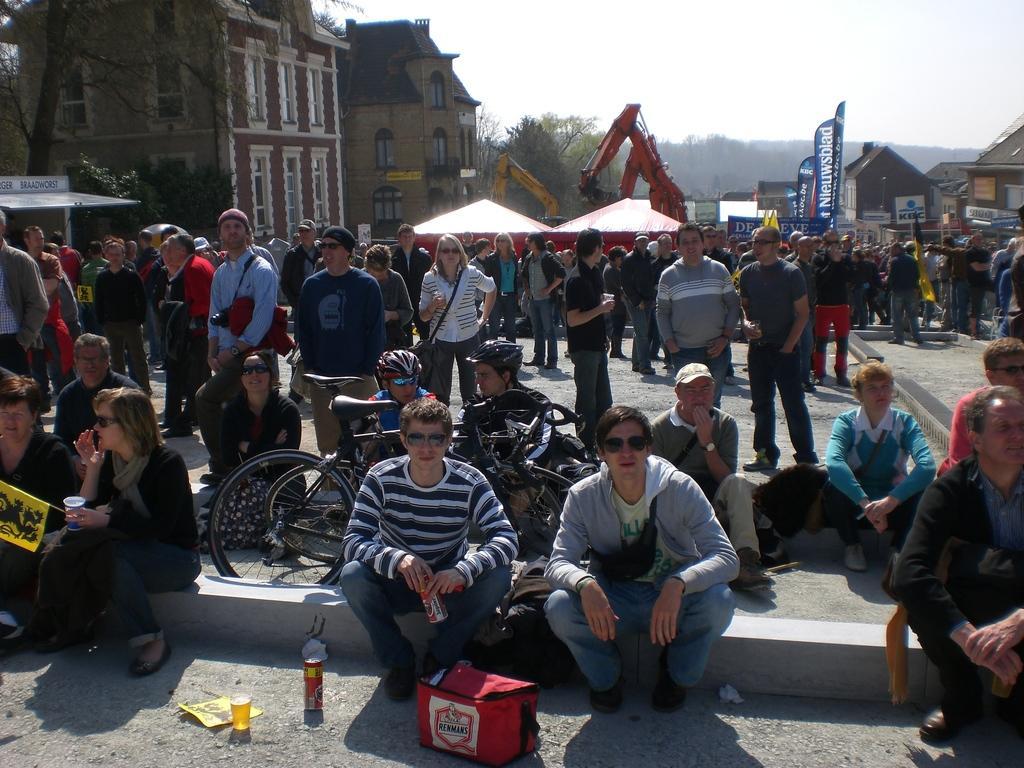Please provide a concise description of this image. This image consists of so many people in the middle. There are buildings on the left side. There is sky at the top. There are trees in the middle. 